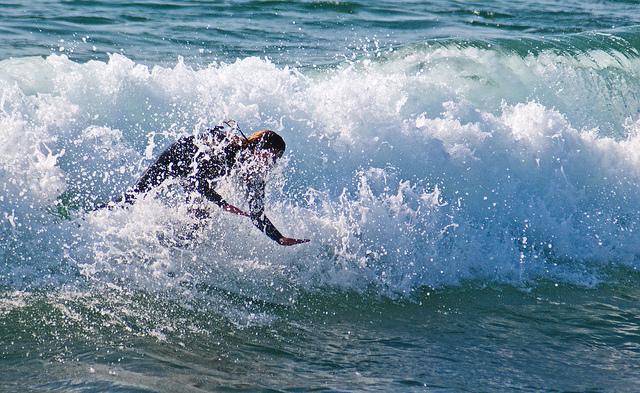Does the surfer have control?
Short answer required. No. Is this person a man?
Concise answer only. No. What color is the water?
Short answer required. Blue. Is the person falling?
Short answer required. Yes. What sport is taking place?
Quick response, please. Surfing. Are these good waves for this sport?
Write a very short answer. Yes. Is the person doing a great job surfing?
Keep it brief. No. Is it a sunny day?
Short answer required. Yes. 